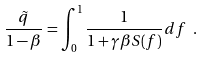Convert formula to latex. <formula><loc_0><loc_0><loc_500><loc_500>\frac { \tilde { q } } { 1 - \beta } = \int _ { 0 } ^ { 1 } \frac { 1 } { 1 + \gamma \beta S ( f ) } d f \ .</formula> 